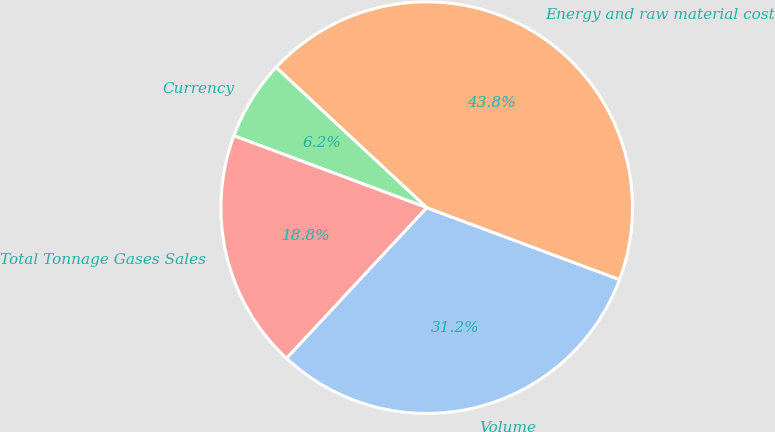Convert chart to OTSL. <chart><loc_0><loc_0><loc_500><loc_500><pie_chart><fcel>Volume<fcel>Energy and raw material cost<fcel>Currency<fcel>Total Tonnage Gases Sales<nl><fcel>31.25%<fcel>43.75%<fcel>6.25%<fcel>18.75%<nl></chart> 